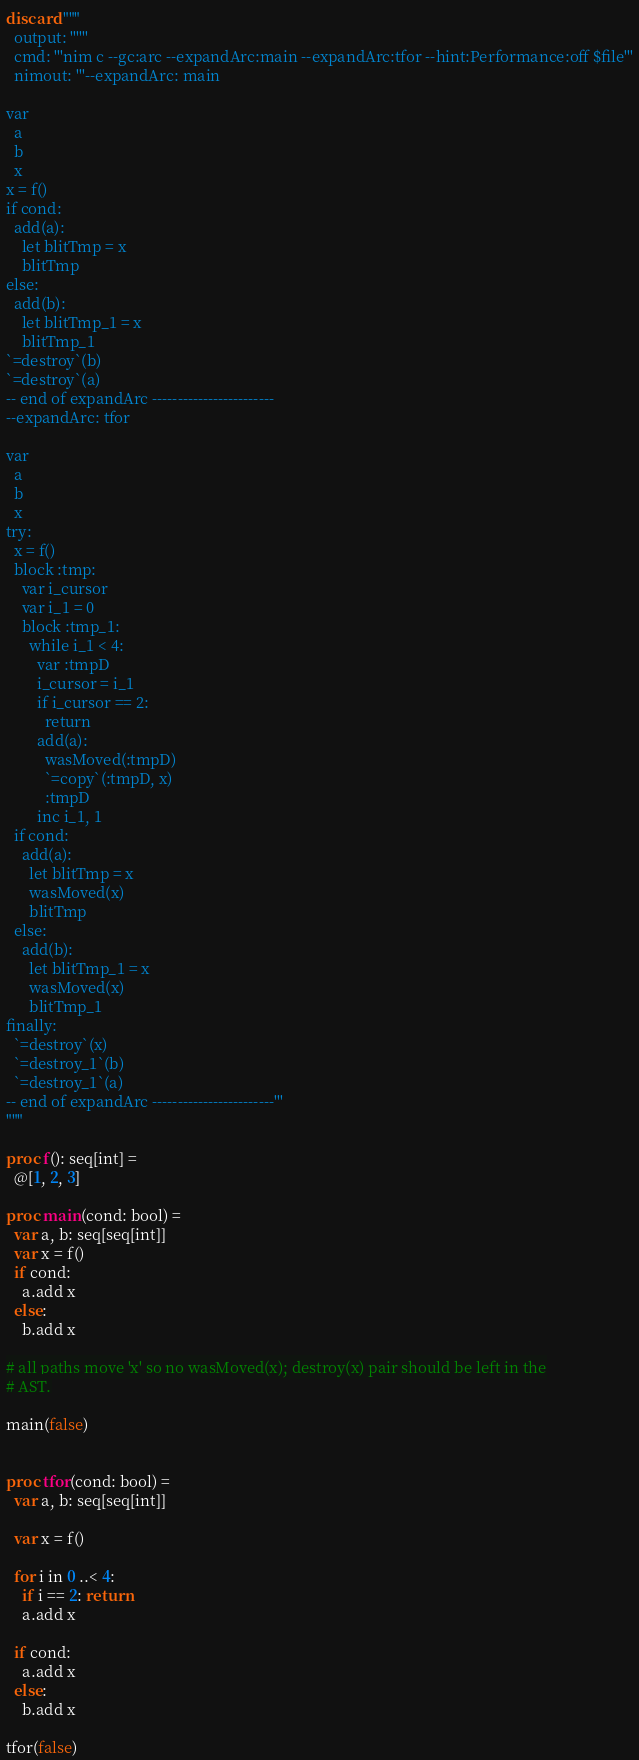Convert code to text. <code><loc_0><loc_0><loc_500><loc_500><_Nim_>discard """
  output: ''''''
  cmd: '''nim c --gc:arc --expandArc:main --expandArc:tfor --hint:Performance:off $file'''
  nimout: '''--expandArc: main

var
  a
  b
  x
x = f()
if cond:
  add(a):
    let blitTmp = x
    blitTmp
else:
  add(b):
    let blitTmp_1 = x
    blitTmp_1
`=destroy`(b)
`=destroy`(a)
-- end of expandArc ------------------------
--expandArc: tfor

var
  a
  b
  x
try:
  x = f()
  block :tmp:
    var i_cursor
    var i_1 = 0
    block :tmp_1:
      while i_1 < 4:
        var :tmpD
        i_cursor = i_1
        if i_cursor == 2:
          return
        add(a):
          wasMoved(:tmpD)
          `=copy`(:tmpD, x)
          :tmpD
        inc i_1, 1
  if cond:
    add(a):
      let blitTmp = x
      wasMoved(x)
      blitTmp
  else:
    add(b):
      let blitTmp_1 = x
      wasMoved(x)
      blitTmp_1
finally:
  `=destroy`(x)
  `=destroy_1`(b)
  `=destroy_1`(a)
-- end of expandArc ------------------------'''
"""

proc f(): seq[int] =
  @[1, 2, 3]

proc main(cond: bool) =
  var a, b: seq[seq[int]]
  var x = f()
  if cond:
    a.add x
  else:
    b.add x

# all paths move 'x' so no wasMoved(x); destroy(x) pair should be left in the
# AST.

main(false)


proc tfor(cond: bool) =
  var a, b: seq[seq[int]]

  var x = f()

  for i in 0 ..< 4:
    if i == 2: return
    a.add x

  if cond:
    a.add x
  else:
    b.add x

tfor(false)
</code> 